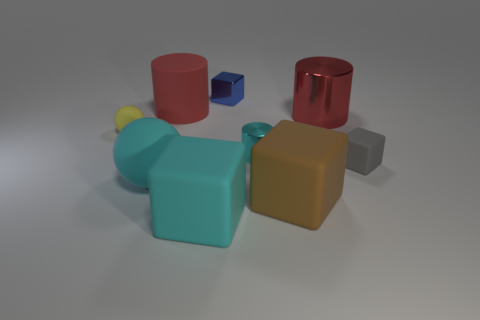Subtract all gray blocks. How many red cylinders are left? 2 Add 1 big spheres. How many objects exist? 10 Subtract all tiny rubber cubes. How many cubes are left? 3 Subtract all blue cubes. How many cubes are left? 3 Subtract all balls. How many objects are left? 7 Add 3 cyan cylinders. How many cyan cylinders are left? 4 Add 6 big yellow matte spheres. How many big yellow matte spheres exist? 6 Subtract 0 purple cylinders. How many objects are left? 9 Subtract all gray cylinders. Subtract all gray cubes. How many cylinders are left? 3 Subtract all yellow metallic cylinders. Subtract all small cyan metallic cylinders. How many objects are left? 8 